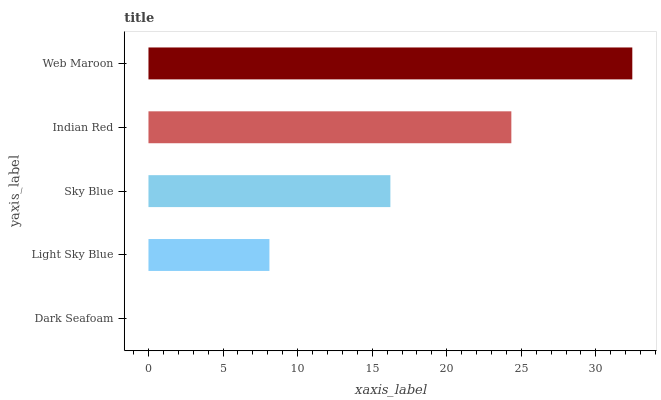Is Dark Seafoam the minimum?
Answer yes or no. Yes. Is Web Maroon the maximum?
Answer yes or no. Yes. Is Light Sky Blue the minimum?
Answer yes or no. No. Is Light Sky Blue the maximum?
Answer yes or no. No. Is Light Sky Blue greater than Dark Seafoam?
Answer yes or no. Yes. Is Dark Seafoam less than Light Sky Blue?
Answer yes or no. Yes. Is Dark Seafoam greater than Light Sky Blue?
Answer yes or no. No. Is Light Sky Blue less than Dark Seafoam?
Answer yes or no. No. Is Sky Blue the high median?
Answer yes or no. Yes. Is Sky Blue the low median?
Answer yes or no. Yes. Is Indian Red the high median?
Answer yes or no. No. Is Light Sky Blue the low median?
Answer yes or no. No. 